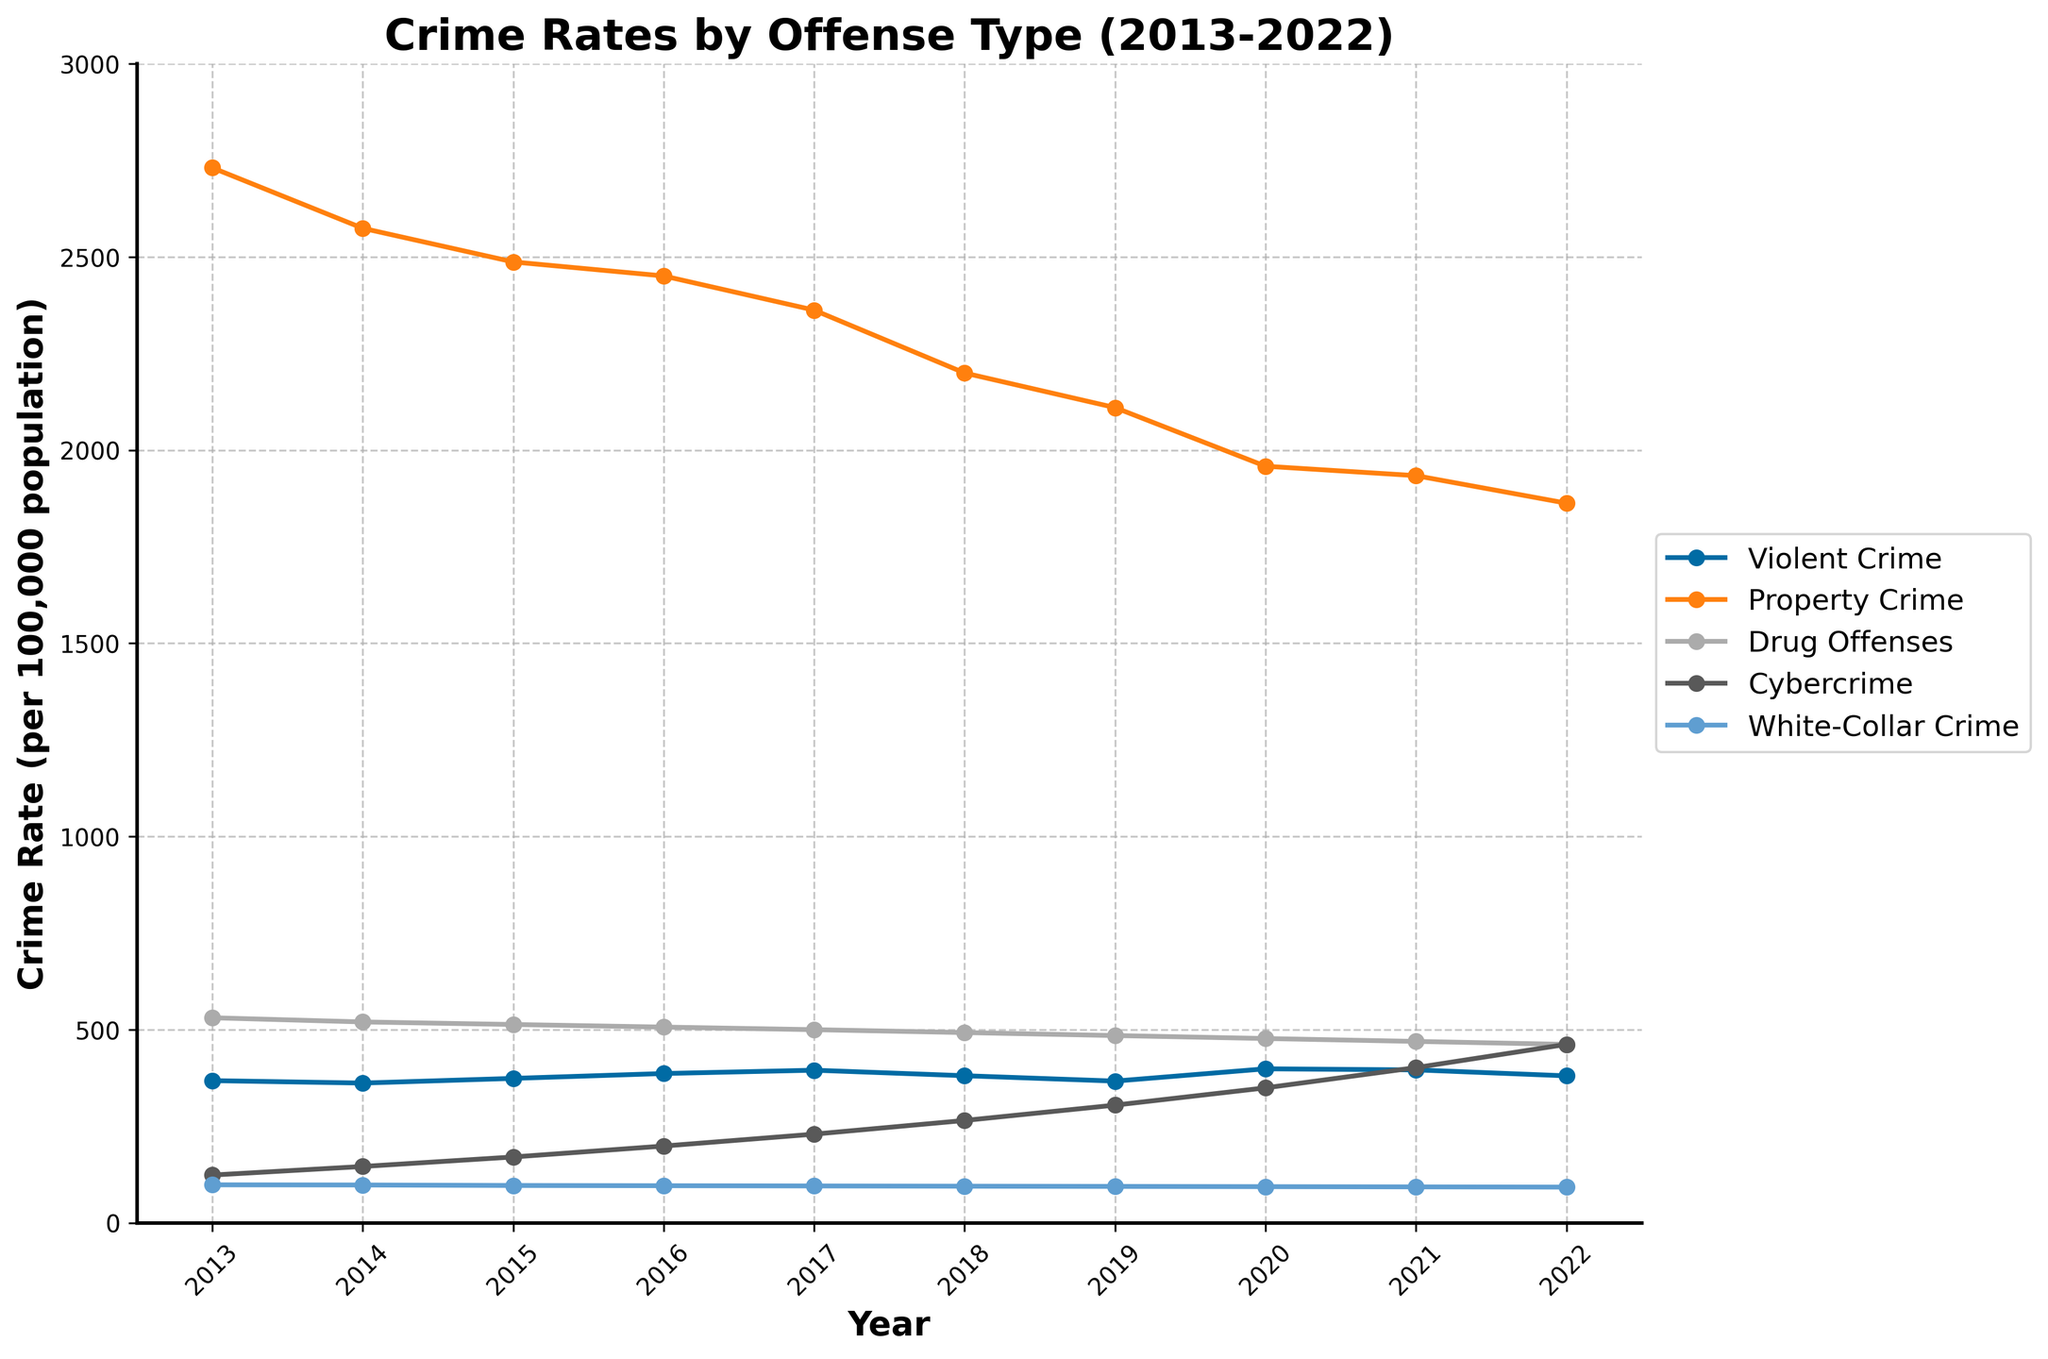What's the trend of Cybercrime rates from 2013 to 2022? The plot shows Cybercrime rates steadily increasing each year from 123.5 in 2013 to 461.8 in 2022.
Answer: Steadily increasing In which year did Violent Crime peak, and what was its rate? The peak of Violent Crime was in 2020 with a rate of 398.5 per 100,000 population.
Answer: 2020, 398.5 Compare the rates of Property Crime and Violent Crime in 2016. Which was higher and by how much? In 2016, Property Crime was 2,450.7 and Violent Crime was 386.3 per 100,000 population. Property Crime was higher by (2450.7 - 386.3) = 2,064.4.
Answer: Property Crime, 2064.4 higher Did any type of crime decrease consistently from 2013 to 2022? If so, which one? Observing the trends, Property Crime rates declined consistently from 2,730.7 in 2013 to 1,862.5 in 2022.
Answer: Property Crime What's the difference between Cybercrime rates in 2013 and 2022? Cybercrime rates in 2022 were 461.8, and in 2013 they were 123.5. The difference is 461.8 - 123.5 = 338.3.
Answer: 338.3 What was the rate of White-Collar Crime in the last recorded year, and how consistent was its trend over the decade? The White-Collar Crime rate in 2022 was 92.3, and its trend was quite consistent, with a slight decrease from 98.2 in 2013 to 92.3 in 2022.
Answer: 92.3, consistent Which type of crime had the highest rate in 2022? In 2022, Property Crime had the highest rate of 1,862.5 per 100,000 population.
Answer: Property Crime Calculate the average rate of Drug Offenses from 2013 to 2022. Sum the Drug Offenses rates from 2013 to 2022: (530.6 + 519.8 + 513.2 + 506.5 + 499.8 + 492.3 + 484.6 + 476.9 + 469.4 + 461.7) = 4,954.8. There are 10 years, so the average is 4954.8 / 10 = 495.48.
Answer: 495.48 In which years did Violent Crime rates exceed 390 per 100,000? Violent Crime rates exceeded 390 in the years 2017, 2020, and 2021 with rates of 394.9, 398.5, and 395.7 respectively.
Answer: 2017, 2020, 2021 